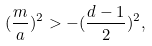Convert formula to latex. <formula><loc_0><loc_0><loc_500><loc_500>( \frac { m } { a } ) ^ { 2 } > - ( \frac { d - 1 } { 2 } ) ^ { 2 } ,</formula> 